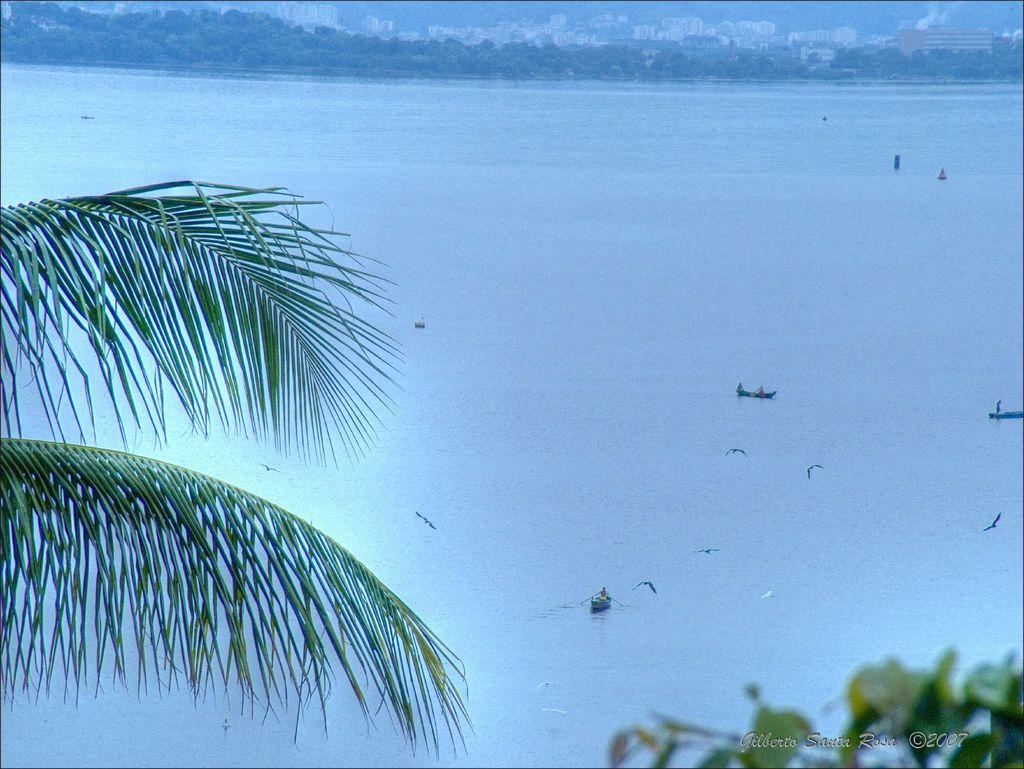What is happening on the water in the image? There are boats on the water in the image. What else is happening in the sky in the image? Birds are flying in the image. What can be seen in the background of the image? There are buildings and trees in the background of the image. Is there any text visible in the image? Yes, there is some text visible in the bottom right corner of the image. Can you see any snails crawling on the boats in the image? There are no snails visible in the image; it features boats on the water and birds flying in the sky. What type of approval is required for the text in the bottom right corner of the image? There is no indication in the image that any approval is required for the text; it is simply a part of the image's composition. 